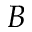Convert formula to latex. <formula><loc_0><loc_0><loc_500><loc_500>B</formula> 